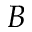Convert formula to latex. <formula><loc_0><loc_0><loc_500><loc_500>B</formula> 